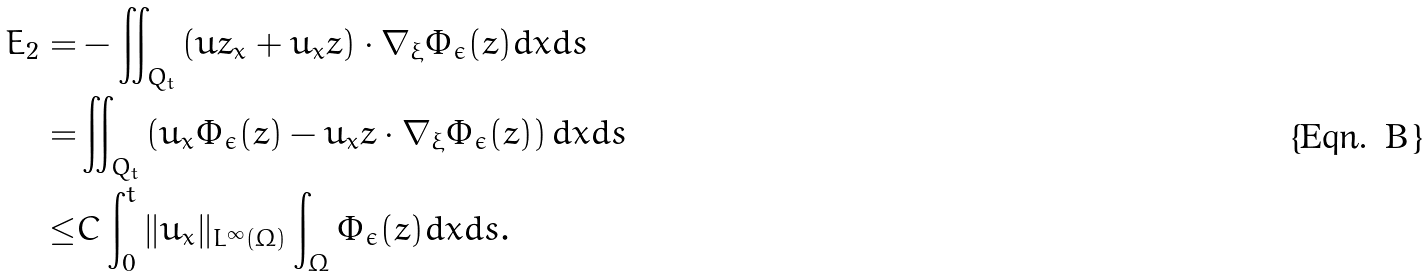Convert formula to latex. <formula><loc_0><loc_0><loc_500><loc_500>E _ { 2 } = & - \iint _ { Q _ { t } } \left ( u z _ { x } + u _ { x } z \right ) \cdot \nabla _ { \xi } \Phi _ { \epsilon } ( z ) d x d s \\ = & \iint _ { Q _ { t } } \left ( u _ { x } \Phi _ { \epsilon } ( z ) - u _ { x } z \cdot \nabla _ { \xi } \Phi _ { \epsilon } ( z ) \right ) d x d s \\ \leq & C \int _ { 0 } ^ { t } \| u _ { x } \| _ { L ^ { \infty } ( \Omega ) } \int _ { \Omega } \Phi _ { \epsilon } ( z ) d x d s .</formula> 